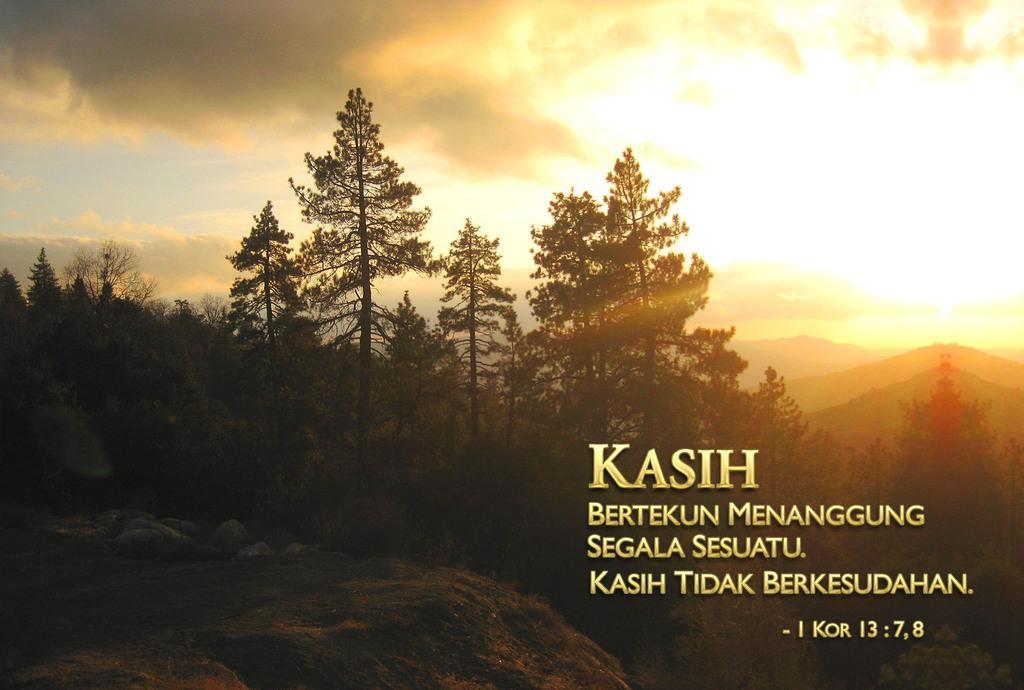How would you summarize this image in a sentence or two? This is an edited picture. In this image there are mountains and trees. In the foreground there are stones. At the top there is sky and there are clouds. On the right side of the image there is text. At the bottom there is grass. 